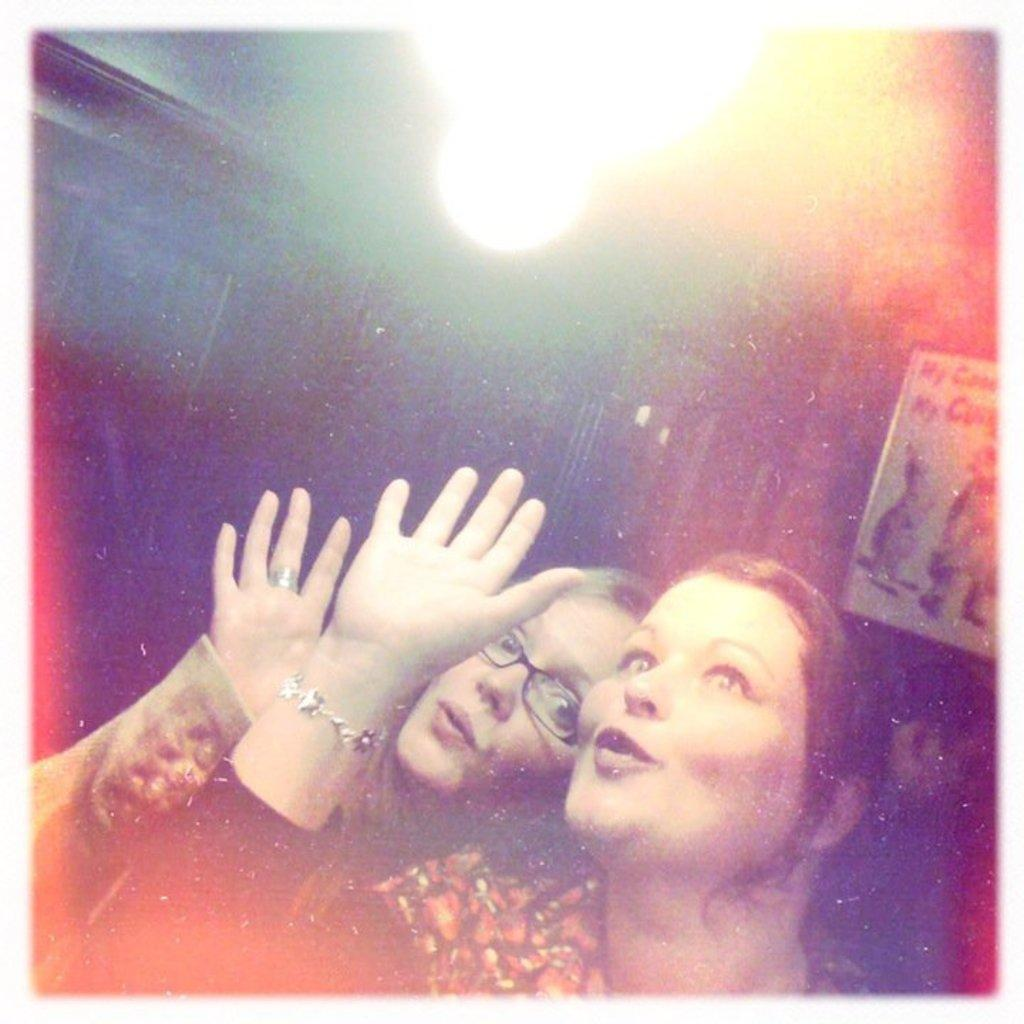How many people are in the image? There are two women in the image. What can be seen in the background of the image? There is a board in the background of the image. What is the source of light visible at the top of the image? The light visible at the top of the image is not specified, but it could be a light fixture or natural light from a window. What type of lace is being used to decorate the faces of the women in the image? There is no lace present in the image, nor are the women's faces being decorated. 